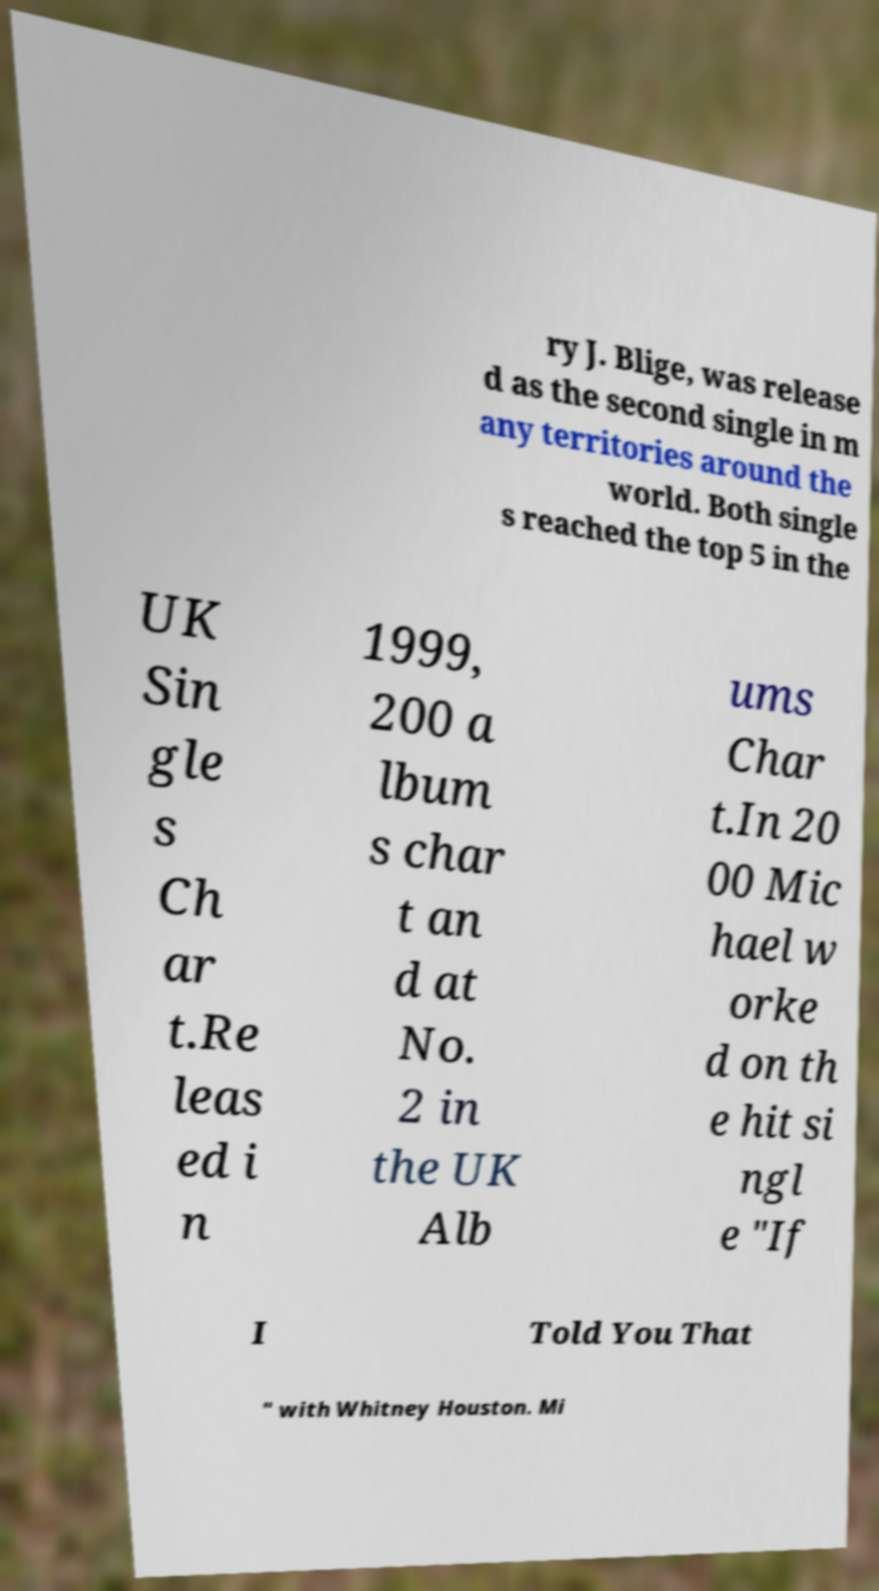Please read and relay the text visible in this image. What does it say? ry J. Blige, was release d as the second single in m any territories around the world. Both single s reached the top 5 in the UK Sin gle s Ch ar t.Re leas ed i n 1999, 200 a lbum s char t an d at No. 2 in the UK Alb ums Char t.In 20 00 Mic hael w orke d on th e hit si ngl e "If I Told You That " with Whitney Houston. Mi 